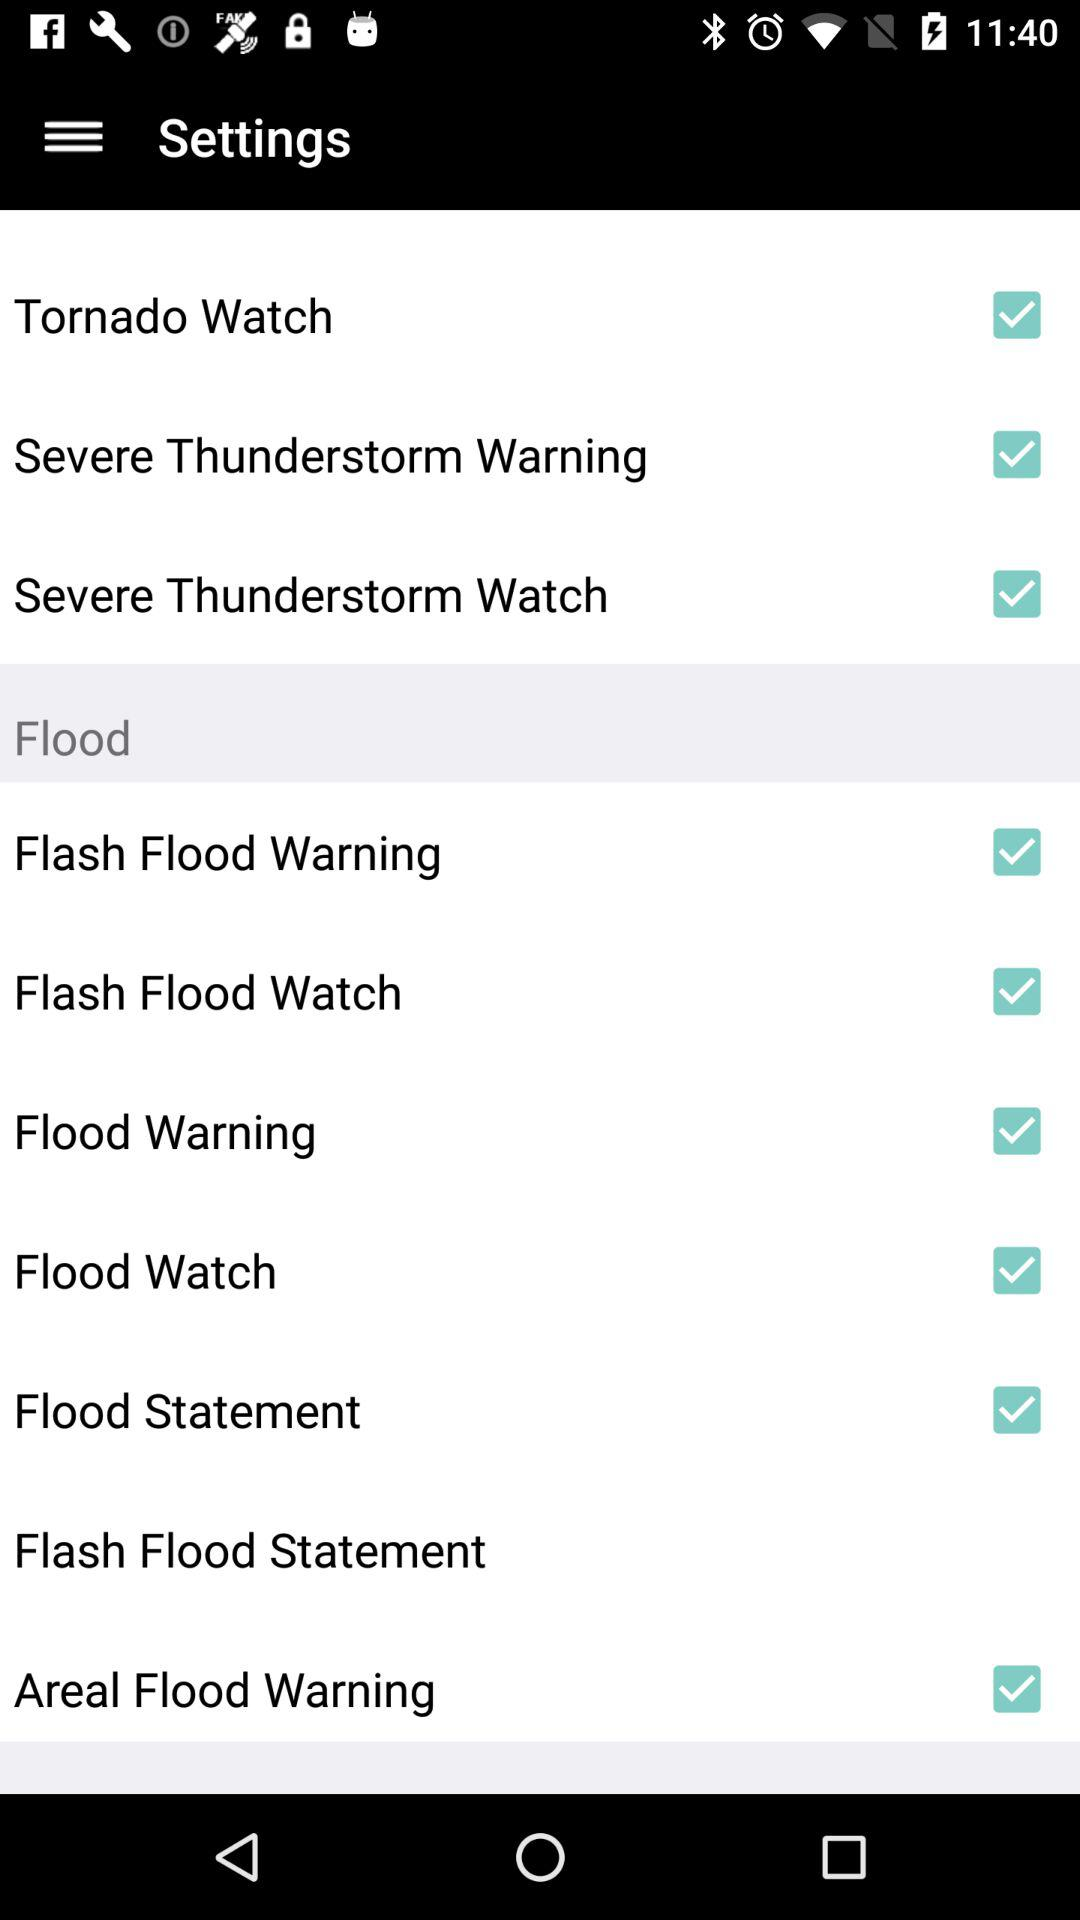What is the status of flood watch? The status is on. 